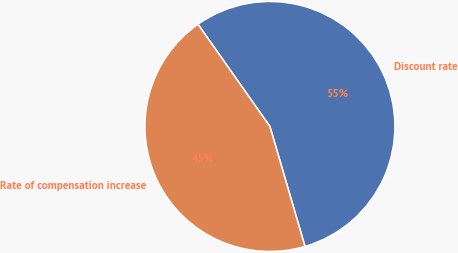Convert chart to OTSL. <chart><loc_0><loc_0><loc_500><loc_500><pie_chart><fcel>Discount rate<fcel>Rate of compensation increase<nl><fcel>55.23%<fcel>44.77%<nl></chart> 